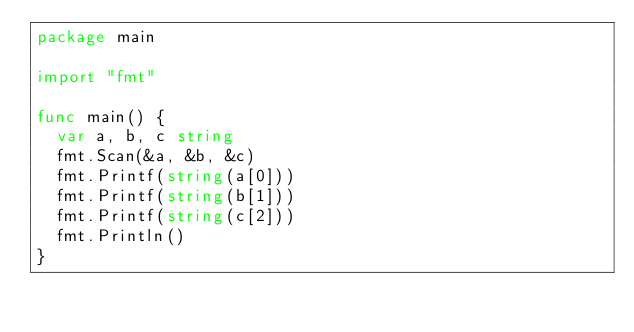<code> <loc_0><loc_0><loc_500><loc_500><_Go_>package main

import "fmt"

func main() {
	var a, b, c string
	fmt.Scan(&a, &b, &c)
	fmt.Printf(string(a[0]))
	fmt.Printf(string(b[1]))
	fmt.Printf(string(c[2]))
	fmt.Println()
}
</code> 